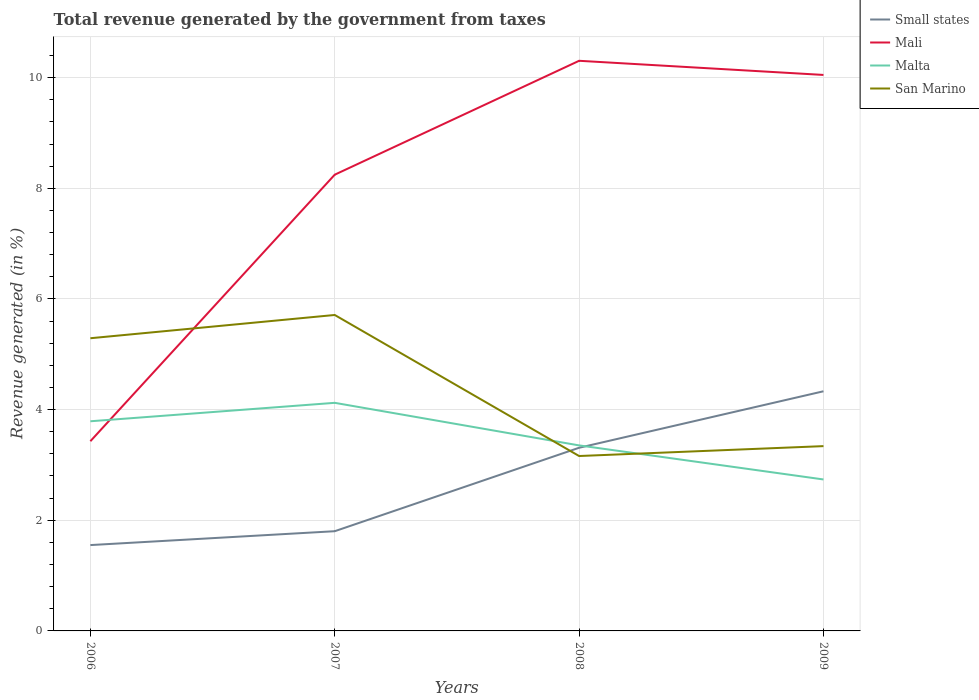Does the line corresponding to San Marino intersect with the line corresponding to Malta?
Offer a very short reply. Yes. Is the number of lines equal to the number of legend labels?
Ensure brevity in your answer.  Yes. Across all years, what is the maximum total revenue generated in Malta?
Ensure brevity in your answer.  2.74. In which year was the total revenue generated in Malta maximum?
Your response must be concise. 2009. What is the total total revenue generated in Mali in the graph?
Your answer should be very brief. -6.62. What is the difference between the highest and the second highest total revenue generated in Malta?
Your answer should be compact. 1.38. What is the difference between two consecutive major ticks on the Y-axis?
Ensure brevity in your answer.  2. Are the values on the major ticks of Y-axis written in scientific E-notation?
Provide a short and direct response. No. Does the graph contain any zero values?
Give a very brief answer. No. What is the title of the graph?
Your answer should be compact. Total revenue generated by the government from taxes. What is the label or title of the Y-axis?
Ensure brevity in your answer.  Revenue generated (in %). What is the Revenue generated (in %) of Small states in 2006?
Offer a terse response. 1.55. What is the Revenue generated (in %) in Mali in 2006?
Make the answer very short. 3.43. What is the Revenue generated (in %) of Malta in 2006?
Offer a terse response. 3.79. What is the Revenue generated (in %) in San Marino in 2006?
Make the answer very short. 5.29. What is the Revenue generated (in %) in Small states in 2007?
Offer a terse response. 1.8. What is the Revenue generated (in %) of Mali in 2007?
Your response must be concise. 8.25. What is the Revenue generated (in %) of Malta in 2007?
Keep it short and to the point. 4.12. What is the Revenue generated (in %) of San Marino in 2007?
Ensure brevity in your answer.  5.71. What is the Revenue generated (in %) of Small states in 2008?
Keep it short and to the point. 3.31. What is the Revenue generated (in %) of Mali in 2008?
Your answer should be very brief. 10.3. What is the Revenue generated (in %) in Malta in 2008?
Provide a short and direct response. 3.35. What is the Revenue generated (in %) in San Marino in 2008?
Provide a short and direct response. 3.16. What is the Revenue generated (in %) in Small states in 2009?
Your answer should be very brief. 4.33. What is the Revenue generated (in %) of Mali in 2009?
Offer a terse response. 10.05. What is the Revenue generated (in %) of Malta in 2009?
Ensure brevity in your answer.  2.74. What is the Revenue generated (in %) in San Marino in 2009?
Offer a terse response. 3.34. Across all years, what is the maximum Revenue generated (in %) in Small states?
Keep it short and to the point. 4.33. Across all years, what is the maximum Revenue generated (in %) of Mali?
Your answer should be compact. 10.3. Across all years, what is the maximum Revenue generated (in %) in Malta?
Offer a terse response. 4.12. Across all years, what is the maximum Revenue generated (in %) in San Marino?
Your answer should be compact. 5.71. Across all years, what is the minimum Revenue generated (in %) in Small states?
Offer a very short reply. 1.55. Across all years, what is the minimum Revenue generated (in %) of Mali?
Your answer should be compact. 3.43. Across all years, what is the minimum Revenue generated (in %) in Malta?
Make the answer very short. 2.74. Across all years, what is the minimum Revenue generated (in %) in San Marino?
Ensure brevity in your answer.  3.16. What is the total Revenue generated (in %) of Small states in the graph?
Make the answer very short. 10.99. What is the total Revenue generated (in %) in Mali in the graph?
Provide a short and direct response. 32.03. What is the total Revenue generated (in %) of Malta in the graph?
Offer a terse response. 14. What is the total Revenue generated (in %) in San Marino in the graph?
Your answer should be very brief. 17.5. What is the difference between the Revenue generated (in %) in Small states in 2006 and that in 2007?
Provide a succinct answer. -0.25. What is the difference between the Revenue generated (in %) in Mali in 2006 and that in 2007?
Offer a terse response. -4.82. What is the difference between the Revenue generated (in %) in Malta in 2006 and that in 2007?
Offer a very short reply. -0.33. What is the difference between the Revenue generated (in %) of San Marino in 2006 and that in 2007?
Provide a short and direct response. -0.42. What is the difference between the Revenue generated (in %) of Small states in 2006 and that in 2008?
Provide a succinct answer. -1.76. What is the difference between the Revenue generated (in %) in Mali in 2006 and that in 2008?
Offer a terse response. -6.88. What is the difference between the Revenue generated (in %) of Malta in 2006 and that in 2008?
Offer a very short reply. 0.44. What is the difference between the Revenue generated (in %) in San Marino in 2006 and that in 2008?
Your answer should be compact. 2.13. What is the difference between the Revenue generated (in %) in Small states in 2006 and that in 2009?
Ensure brevity in your answer.  -2.78. What is the difference between the Revenue generated (in %) of Mali in 2006 and that in 2009?
Offer a very short reply. -6.62. What is the difference between the Revenue generated (in %) of Malta in 2006 and that in 2009?
Offer a very short reply. 1.05. What is the difference between the Revenue generated (in %) of San Marino in 2006 and that in 2009?
Your response must be concise. 1.95. What is the difference between the Revenue generated (in %) of Small states in 2007 and that in 2008?
Give a very brief answer. -1.51. What is the difference between the Revenue generated (in %) in Mali in 2007 and that in 2008?
Offer a very short reply. -2.06. What is the difference between the Revenue generated (in %) of Malta in 2007 and that in 2008?
Give a very brief answer. 0.77. What is the difference between the Revenue generated (in %) in San Marino in 2007 and that in 2008?
Your answer should be compact. 2.55. What is the difference between the Revenue generated (in %) of Small states in 2007 and that in 2009?
Your response must be concise. -2.53. What is the difference between the Revenue generated (in %) in Mali in 2007 and that in 2009?
Provide a short and direct response. -1.8. What is the difference between the Revenue generated (in %) in Malta in 2007 and that in 2009?
Offer a terse response. 1.38. What is the difference between the Revenue generated (in %) of San Marino in 2007 and that in 2009?
Your answer should be compact. 2.37. What is the difference between the Revenue generated (in %) of Small states in 2008 and that in 2009?
Make the answer very short. -1.02. What is the difference between the Revenue generated (in %) in Mali in 2008 and that in 2009?
Your response must be concise. 0.26. What is the difference between the Revenue generated (in %) of Malta in 2008 and that in 2009?
Give a very brief answer. 0.62. What is the difference between the Revenue generated (in %) in San Marino in 2008 and that in 2009?
Your answer should be very brief. -0.18. What is the difference between the Revenue generated (in %) in Small states in 2006 and the Revenue generated (in %) in Mali in 2007?
Your answer should be very brief. -6.69. What is the difference between the Revenue generated (in %) of Small states in 2006 and the Revenue generated (in %) of Malta in 2007?
Offer a very short reply. -2.57. What is the difference between the Revenue generated (in %) in Small states in 2006 and the Revenue generated (in %) in San Marino in 2007?
Your answer should be compact. -4.16. What is the difference between the Revenue generated (in %) of Mali in 2006 and the Revenue generated (in %) of Malta in 2007?
Keep it short and to the point. -0.69. What is the difference between the Revenue generated (in %) of Mali in 2006 and the Revenue generated (in %) of San Marino in 2007?
Give a very brief answer. -2.28. What is the difference between the Revenue generated (in %) in Malta in 2006 and the Revenue generated (in %) in San Marino in 2007?
Keep it short and to the point. -1.92. What is the difference between the Revenue generated (in %) of Small states in 2006 and the Revenue generated (in %) of Mali in 2008?
Your answer should be very brief. -8.75. What is the difference between the Revenue generated (in %) in Small states in 2006 and the Revenue generated (in %) in Malta in 2008?
Provide a succinct answer. -1.8. What is the difference between the Revenue generated (in %) in Small states in 2006 and the Revenue generated (in %) in San Marino in 2008?
Offer a very short reply. -1.61. What is the difference between the Revenue generated (in %) in Mali in 2006 and the Revenue generated (in %) in Malta in 2008?
Ensure brevity in your answer.  0.08. What is the difference between the Revenue generated (in %) of Mali in 2006 and the Revenue generated (in %) of San Marino in 2008?
Provide a succinct answer. 0.27. What is the difference between the Revenue generated (in %) of Malta in 2006 and the Revenue generated (in %) of San Marino in 2008?
Your answer should be compact. 0.63. What is the difference between the Revenue generated (in %) of Small states in 2006 and the Revenue generated (in %) of Mali in 2009?
Make the answer very short. -8.5. What is the difference between the Revenue generated (in %) of Small states in 2006 and the Revenue generated (in %) of Malta in 2009?
Provide a short and direct response. -1.19. What is the difference between the Revenue generated (in %) in Small states in 2006 and the Revenue generated (in %) in San Marino in 2009?
Provide a succinct answer. -1.79. What is the difference between the Revenue generated (in %) in Mali in 2006 and the Revenue generated (in %) in Malta in 2009?
Give a very brief answer. 0.69. What is the difference between the Revenue generated (in %) of Mali in 2006 and the Revenue generated (in %) of San Marino in 2009?
Provide a short and direct response. 0.09. What is the difference between the Revenue generated (in %) in Malta in 2006 and the Revenue generated (in %) in San Marino in 2009?
Your answer should be compact. 0.45. What is the difference between the Revenue generated (in %) of Small states in 2007 and the Revenue generated (in %) of Mali in 2008?
Your response must be concise. -8.5. What is the difference between the Revenue generated (in %) of Small states in 2007 and the Revenue generated (in %) of Malta in 2008?
Offer a very short reply. -1.55. What is the difference between the Revenue generated (in %) in Small states in 2007 and the Revenue generated (in %) in San Marino in 2008?
Make the answer very short. -1.36. What is the difference between the Revenue generated (in %) of Mali in 2007 and the Revenue generated (in %) of Malta in 2008?
Your response must be concise. 4.89. What is the difference between the Revenue generated (in %) of Mali in 2007 and the Revenue generated (in %) of San Marino in 2008?
Give a very brief answer. 5.08. What is the difference between the Revenue generated (in %) of Malta in 2007 and the Revenue generated (in %) of San Marino in 2008?
Your response must be concise. 0.96. What is the difference between the Revenue generated (in %) in Small states in 2007 and the Revenue generated (in %) in Mali in 2009?
Provide a succinct answer. -8.25. What is the difference between the Revenue generated (in %) in Small states in 2007 and the Revenue generated (in %) in Malta in 2009?
Make the answer very short. -0.94. What is the difference between the Revenue generated (in %) of Small states in 2007 and the Revenue generated (in %) of San Marino in 2009?
Your answer should be compact. -1.54. What is the difference between the Revenue generated (in %) of Mali in 2007 and the Revenue generated (in %) of Malta in 2009?
Your answer should be compact. 5.51. What is the difference between the Revenue generated (in %) of Mali in 2007 and the Revenue generated (in %) of San Marino in 2009?
Provide a short and direct response. 4.91. What is the difference between the Revenue generated (in %) of Malta in 2007 and the Revenue generated (in %) of San Marino in 2009?
Give a very brief answer. 0.78. What is the difference between the Revenue generated (in %) in Small states in 2008 and the Revenue generated (in %) in Mali in 2009?
Provide a succinct answer. -6.74. What is the difference between the Revenue generated (in %) of Small states in 2008 and the Revenue generated (in %) of Malta in 2009?
Offer a very short reply. 0.57. What is the difference between the Revenue generated (in %) of Small states in 2008 and the Revenue generated (in %) of San Marino in 2009?
Keep it short and to the point. -0.03. What is the difference between the Revenue generated (in %) in Mali in 2008 and the Revenue generated (in %) in Malta in 2009?
Your answer should be very brief. 7.57. What is the difference between the Revenue generated (in %) of Mali in 2008 and the Revenue generated (in %) of San Marino in 2009?
Your answer should be compact. 6.96. What is the difference between the Revenue generated (in %) in Malta in 2008 and the Revenue generated (in %) in San Marino in 2009?
Offer a terse response. 0.01. What is the average Revenue generated (in %) in Small states per year?
Make the answer very short. 2.75. What is the average Revenue generated (in %) of Mali per year?
Offer a very short reply. 8.01. What is the average Revenue generated (in %) of Malta per year?
Make the answer very short. 3.5. What is the average Revenue generated (in %) of San Marino per year?
Provide a succinct answer. 4.38. In the year 2006, what is the difference between the Revenue generated (in %) of Small states and Revenue generated (in %) of Mali?
Provide a succinct answer. -1.88. In the year 2006, what is the difference between the Revenue generated (in %) in Small states and Revenue generated (in %) in Malta?
Offer a very short reply. -2.24. In the year 2006, what is the difference between the Revenue generated (in %) in Small states and Revenue generated (in %) in San Marino?
Provide a short and direct response. -3.74. In the year 2006, what is the difference between the Revenue generated (in %) in Mali and Revenue generated (in %) in Malta?
Make the answer very short. -0.36. In the year 2006, what is the difference between the Revenue generated (in %) in Mali and Revenue generated (in %) in San Marino?
Keep it short and to the point. -1.86. In the year 2006, what is the difference between the Revenue generated (in %) of Malta and Revenue generated (in %) of San Marino?
Provide a succinct answer. -1.5. In the year 2007, what is the difference between the Revenue generated (in %) in Small states and Revenue generated (in %) in Mali?
Make the answer very short. -6.44. In the year 2007, what is the difference between the Revenue generated (in %) of Small states and Revenue generated (in %) of Malta?
Provide a short and direct response. -2.32. In the year 2007, what is the difference between the Revenue generated (in %) of Small states and Revenue generated (in %) of San Marino?
Offer a terse response. -3.91. In the year 2007, what is the difference between the Revenue generated (in %) in Mali and Revenue generated (in %) in Malta?
Offer a terse response. 4.12. In the year 2007, what is the difference between the Revenue generated (in %) of Mali and Revenue generated (in %) of San Marino?
Provide a succinct answer. 2.54. In the year 2007, what is the difference between the Revenue generated (in %) of Malta and Revenue generated (in %) of San Marino?
Your response must be concise. -1.59. In the year 2008, what is the difference between the Revenue generated (in %) of Small states and Revenue generated (in %) of Mali?
Make the answer very short. -6.99. In the year 2008, what is the difference between the Revenue generated (in %) of Small states and Revenue generated (in %) of Malta?
Give a very brief answer. -0.04. In the year 2008, what is the difference between the Revenue generated (in %) in Small states and Revenue generated (in %) in San Marino?
Make the answer very short. 0.15. In the year 2008, what is the difference between the Revenue generated (in %) of Mali and Revenue generated (in %) of Malta?
Your response must be concise. 6.95. In the year 2008, what is the difference between the Revenue generated (in %) of Mali and Revenue generated (in %) of San Marino?
Offer a terse response. 7.14. In the year 2008, what is the difference between the Revenue generated (in %) of Malta and Revenue generated (in %) of San Marino?
Give a very brief answer. 0.19. In the year 2009, what is the difference between the Revenue generated (in %) in Small states and Revenue generated (in %) in Mali?
Offer a very short reply. -5.72. In the year 2009, what is the difference between the Revenue generated (in %) of Small states and Revenue generated (in %) of Malta?
Offer a terse response. 1.59. In the year 2009, what is the difference between the Revenue generated (in %) of Small states and Revenue generated (in %) of San Marino?
Give a very brief answer. 0.99. In the year 2009, what is the difference between the Revenue generated (in %) in Mali and Revenue generated (in %) in Malta?
Give a very brief answer. 7.31. In the year 2009, what is the difference between the Revenue generated (in %) of Mali and Revenue generated (in %) of San Marino?
Your response must be concise. 6.71. In the year 2009, what is the difference between the Revenue generated (in %) of Malta and Revenue generated (in %) of San Marino?
Keep it short and to the point. -0.6. What is the ratio of the Revenue generated (in %) of Small states in 2006 to that in 2007?
Ensure brevity in your answer.  0.86. What is the ratio of the Revenue generated (in %) of Mali in 2006 to that in 2007?
Offer a very short reply. 0.42. What is the ratio of the Revenue generated (in %) in Malta in 2006 to that in 2007?
Offer a terse response. 0.92. What is the ratio of the Revenue generated (in %) in San Marino in 2006 to that in 2007?
Keep it short and to the point. 0.93. What is the ratio of the Revenue generated (in %) in Small states in 2006 to that in 2008?
Make the answer very short. 0.47. What is the ratio of the Revenue generated (in %) in Mali in 2006 to that in 2008?
Your response must be concise. 0.33. What is the ratio of the Revenue generated (in %) of Malta in 2006 to that in 2008?
Offer a very short reply. 1.13. What is the ratio of the Revenue generated (in %) of San Marino in 2006 to that in 2008?
Make the answer very short. 1.67. What is the ratio of the Revenue generated (in %) in Small states in 2006 to that in 2009?
Provide a short and direct response. 0.36. What is the ratio of the Revenue generated (in %) of Mali in 2006 to that in 2009?
Keep it short and to the point. 0.34. What is the ratio of the Revenue generated (in %) in Malta in 2006 to that in 2009?
Your response must be concise. 1.38. What is the ratio of the Revenue generated (in %) in San Marino in 2006 to that in 2009?
Offer a terse response. 1.58. What is the ratio of the Revenue generated (in %) in Small states in 2007 to that in 2008?
Offer a terse response. 0.54. What is the ratio of the Revenue generated (in %) in Mali in 2007 to that in 2008?
Provide a short and direct response. 0.8. What is the ratio of the Revenue generated (in %) in Malta in 2007 to that in 2008?
Your answer should be compact. 1.23. What is the ratio of the Revenue generated (in %) in San Marino in 2007 to that in 2008?
Offer a very short reply. 1.81. What is the ratio of the Revenue generated (in %) of Small states in 2007 to that in 2009?
Your answer should be very brief. 0.42. What is the ratio of the Revenue generated (in %) in Mali in 2007 to that in 2009?
Provide a short and direct response. 0.82. What is the ratio of the Revenue generated (in %) of Malta in 2007 to that in 2009?
Provide a succinct answer. 1.51. What is the ratio of the Revenue generated (in %) in San Marino in 2007 to that in 2009?
Give a very brief answer. 1.71. What is the ratio of the Revenue generated (in %) of Small states in 2008 to that in 2009?
Give a very brief answer. 0.76. What is the ratio of the Revenue generated (in %) of Mali in 2008 to that in 2009?
Keep it short and to the point. 1.03. What is the ratio of the Revenue generated (in %) of Malta in 2008 to that in 2009?
Provide a short and direct response. 1.22. What is the ratio of the Revenue generated (in %) of San Marino in 2008 to that in 2009?
Give a very brief answer. 0.95. What is the difference between the highest and the second highest Revenue generated (in %) of Small states?
Offer a very short reply. 1.02. What is the difference between the highest and the second highest Revenue generated (in %) in Mali?
Your answer should be compact. 0.26. What is the difference between the highest and the second highest Revenue generated (in %) in Malta?
Offer a very short reply. 0.33. What is the difference between the highest and the second highest Revenue generated (in %) of San Marino?
Provide a succinct answer. 0.42. What is the difference between the highest and the lowest Revenue generated (in %) of Small states?
Your answer should be very brief. 2.78. What is the difference between the highest and the lowest Revenue generated (in %) in Mali?
Provide a succinct answer. 6.88. What is the difference between the highest and the lowest Revenue generated (in %) in Malta?
Provide a short and direct response. 1.38. What is the difference between the highest and the lowest Revenue generated (in %) in San Marino?
Your answer should be very brief. 2.55. 